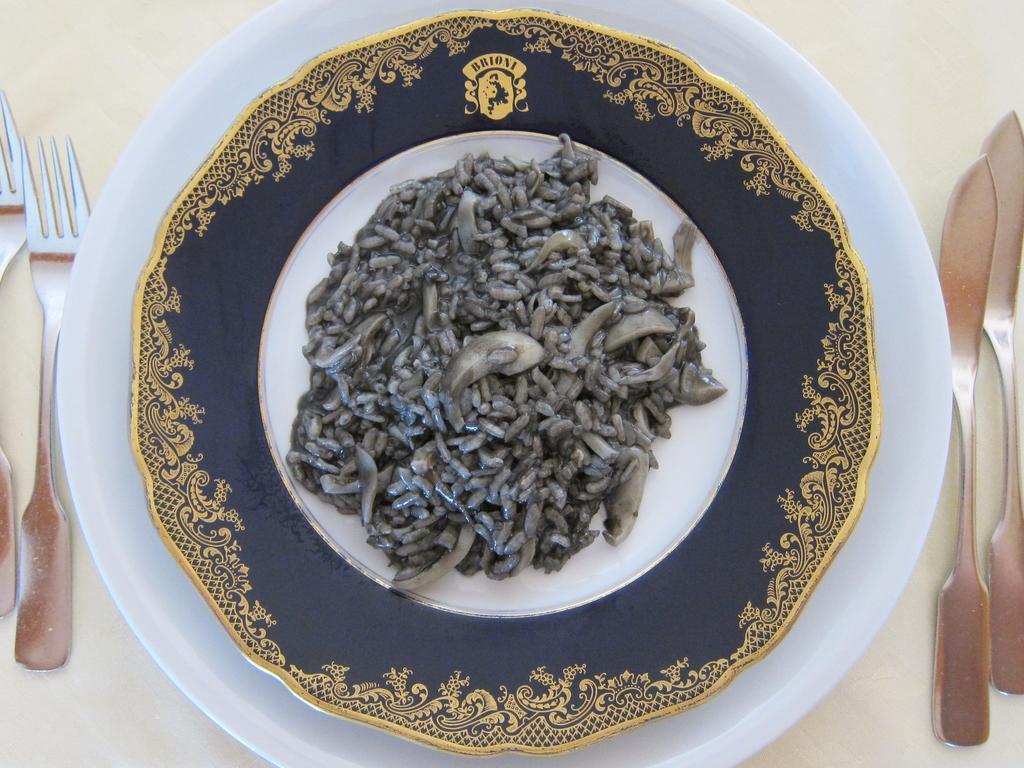Can you describe this image briefly? In this picture we can see plates, food, knives and forks on the white platform. 